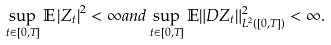Convert formula to latex. <formula><loc_0><loc_0><loc_500><loc_500>\sup _ { t \in [ 0 , T ] } \mathbb { E } \left | Z _ { t } \right | ^ { 2 } < \infty a n d \sup _ { t \in [ 0 , T ] } \mathbb { E } \| D Z _ { t } \| ^ { 2 } _ { L ^ { 2 } ( [ 0 , T ] ) } < \infty .</formula> 